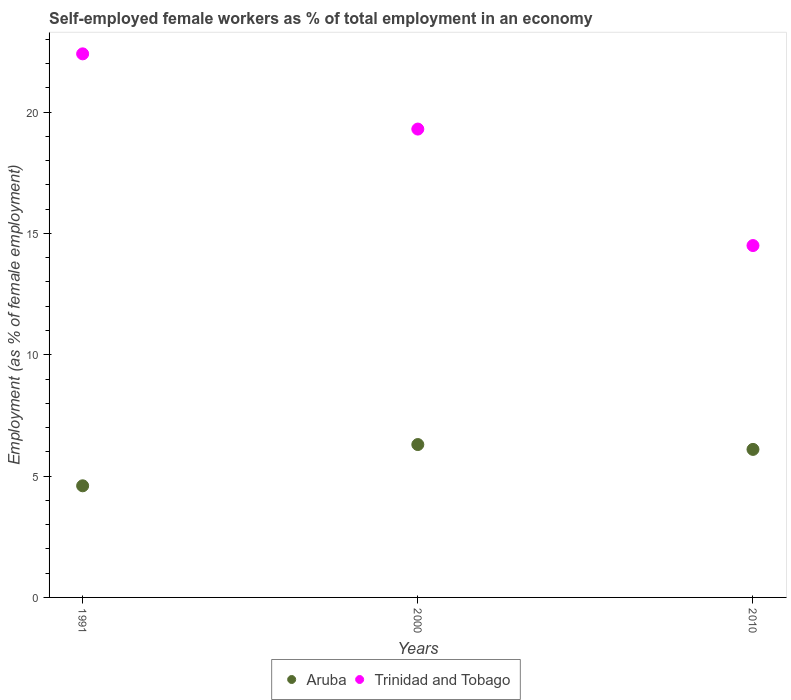How many different coloured dotlines are there?
Offer a very short reply. 2. Is the number of dotlines equal to the number of legend labels?
Your response must be concise. Yes. What is the percentage of self-employed female workers in Aruba in 2010?
Provide a succinct answer. 6.1. Across all years, what is the maximum percentage of self-employed female workers in Trinidad and Tobago?
Make the answer very short. 22.4. Across all years, what is the minimum percentage of self-employed female workers in Aruba?
Keep it short and to the point. 4.6. What is the total percentage of self-employed female workers in Trinidad and Tobago in the graph?
Your response must be concise. 56.2. What is the difference between the percentage of self-employed female workers in Trinidad and Tobago in 2000 and that in 2010?
Make the answer very short. 4.8. What is the difference between the percentage of self-employed female workers in Aruba in 2000 and the percentage of self-employed female workers in Trinidad and Tobago in 2010?
Offer a very short reply. -8.2. What is the average percentage of self-employed female workers in Trinidad and Tobago per year?
Give a very brief answer. 18.73. In the year 2000, what is the difference between the percentage of self-employed female workers in Aruba and percentage of self-employed female workers in Trinidad and Tobago?
Your answer should be compact. -13. What is the ratio of the percentage of self-employed female workers in Trinidad and Tobago in 1991 to that in 2000?
Offer a very short reply. 1.16. Is the percentage of self-employed female workers in Trinidad and Tobago in 1991 less than that in 2010?
Make the answer very short. No. What is the difference between the highest and the second highest percentage of self-employed female workers in Trinidad and Tobago?
Offer a terse response. 3.1. What is the difference between the highest and the lowest percentage of self-employed female workers in Trinidad and Tobago?
Offer a very short reply. 7.9. In how many years, is the percentage of self-employed female workers in Aruba greater than the average percentage of self-employed female workers in Aruba taken over all years?
Make the answer very short. 2. Is the percentage of self-employed female workers in Trinidad and Tobago strictly less than the percentage of self-employed female workers in Aruba over the years?
Offer a very short reply. No. What is the difference between two consecutive major ticks on the Y-axis?
Provide a succinct answer. 5. Are the values on the major ticks of Y-axis written in scientific E-notation?
Offer a very short reply. No. Does the graph contain any zero values?
Your answer should be very brief. No. How many legend labels are there?
Keep it short and to the point. 2. How are the legend labels stacked?
Offer a terse response. Horizontal. What is the title of the graph?
Make the answer very short. Self-employed female workers as % of total employment in an economy. Does "Azerbaijan" appear as one of the legend labels in the graph?
Ensure brevity in your answer.  No. What is the label or title of the Y-axis?
Your response must be concise. Employment (as % of female employment). What is the Employment (as % of female employment) in Aruba in 1991?
Provide a short and direct response. 4.6. What is the Employment (as % of female employment) of Trinidad and Tobago in 1991?
Your answer should be compact. 22.4. What is the Employment (as % of female employment) of Aruba in 2000?
Your response must be concise. 6.3. What is the Employment (as % of female employment) of Trinidad and Tobago in 2000?
Keep it short and to the point. 19.3. What is the Employment (as % of female employment) of Aruba in 2010?
Offer a very short reply. 6.1. Across all years, what is the maximum Employment (as % of female employment) in Aruba?
Keep it short and to the point. 6.3. Across all years, what is the maximum Employment (as % of female employment) of Trinidad and Tobago?
Your answer should be very brief. 22.4. Across all years, what is the minimum Employment (as % of female employment) of Aruba?
Make the answer very short. 4.6. What is the total Employment (as % of female employment) in Aruba in the graph?
Your response must be concise. 17. What is the total Employment (as % of female employment) of Trinidad and Tobago in the graph?
Your response must be concise. 56.2. What is the difference between the Employment (as % of female employment) of Trinidad and Tobago in 1991 and that in 2000?
Provide a succinct answer. 3.1. What is the difference between the Employment (as % of female employment) of Aruba in 1991 and that in 2010?
Offer a very short reply. -1.5. What is the difference between the Employment (as % of female employment) of Aruba in 1991 and the Employment (as % of female employment) of Trinidad and Tobago in 2000?
Your response must be concise. -14.7. What is the difference between the Employment (as % of female employment) in Aruba in 1991 and the Employment (as % of female employment) in Trinidad and Tobago in 2010?
Provide a short and direct response. -9.9. What is the difference between the Employment (as % of female employment) in Aruba in 2000 and the Employment (as % of female employment) in Trinidad and Tobago in 2010?
Offer a very short reply. -8.2. What is the average Employment (as % of female employment) in Aruba per year?
Offer a terse response. 5.67. What is the average Employment (as % of female employment) of Trinidad and Tobago per year?
Offer a very short reply. 18.73. In the year 1991, what is the difference between the Employment (as % of female employment) of Aruba and Employment (as % of female employment) of Trinidad and Tobago?
Your response must be concise. -17.8. In the year 2000, what is the difference between the Employment (as % of female employment) of Aruba and Employment (as % of female employment) of Trinidad and Tobago?
Ensure brevity in your answer.  -13. What is the ratio of the Employment (as % of female employment) of Aruba in 1991 to that in 2000?
Ensure brevity in your answer.  0.73. What is the ratio of the Employment (as % of female employment) in Trinidad and Tobago in 1991 to that in 2000?
Your answer should be very brief. 1.16. What is the ratio of the Employment (as % of female employment) in Aruba in 1991 to that in 2010?
Ensure brevity in your answer.  0.75. What is the ratio of the Employment (as % of female employment) of Trinidad and Tobago in 1991 to that in 2010?
Make the answer very short. 1.54. What is the ratio of the Employment (as % of female employment) of Aruba in 2000 to that in 2010?
Keep it short and to the point. 1.03. What is the ratio of the Employment (as % of female employment) of Trinidad and Tobago in 2000 to that in 2010?
Keep it short and to the point. 1.33. What is the difference between the highest and the lowest Employment (as % of female employment) of Aruba?
Your answer should be very brief. 1.7. What is the difference between the highest and the lowest Employment (as % of female employment) of Trinidad and Tobago?
Make the answer very short. 7.9. 